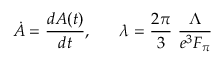<formula> <loc_0><loc_0><loc_500><loc_500>\dot { A } = \frac { d A ( t ) } { d t } , \lambda = \frac { 2 \pi } { 3 } \frac { \Lambda } { e ^ { 3 } F _ { \pi } }</formula> 